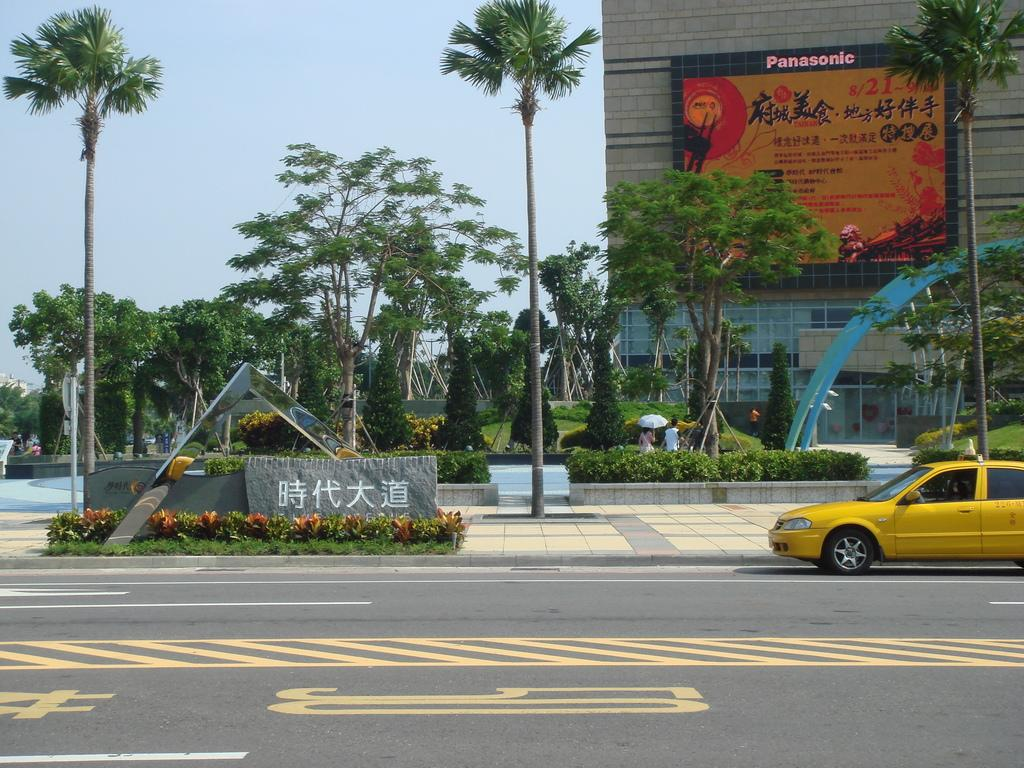Provide a one-sentence caption for the provided image. a building that has the word Panasonic on it. 